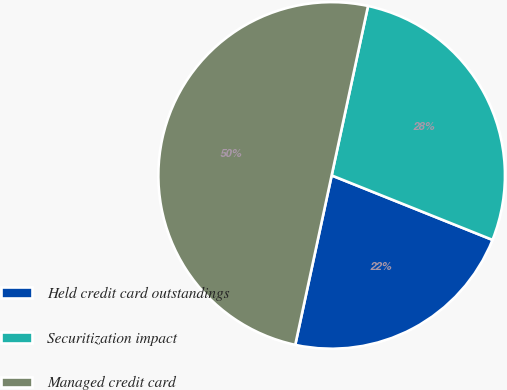Convert chart to OTSL. <chart><loc_0><loc_0><loc_500><loc_500><pie_chart><fcel>Held credit card outstandings<fcel>Securitization impact<fcel>Managed credit card<nl><fcel>22.3%<fcel>27.7%<fcel>50.0%<nl></chart> 